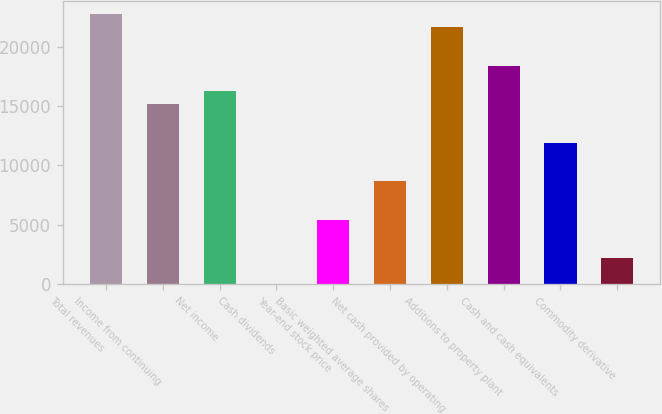<chart> <loc_0><loc_0><loc_500><loc_500><bar_chart><fcel>Total revenues<fcel>Income from continuing<fcel>Net income<fcel>Cash dividends<fcel>Year-end stock price<fcel>Basic weighted average shares<fcel>Net cash provided by operating<fcel>Additions to property plant<fcel>Cash and cash equivalents<fcel>Commodity derivative<nl><fcel>22744.7<fcel>15163.3<fcel>16246.3<fcel>0.43<fcel>5415.73<fcel>8664.91<fcel>21661.6<fcel>18412.5<fcel>11914.1<fcel>2166.55<nl></chart> 